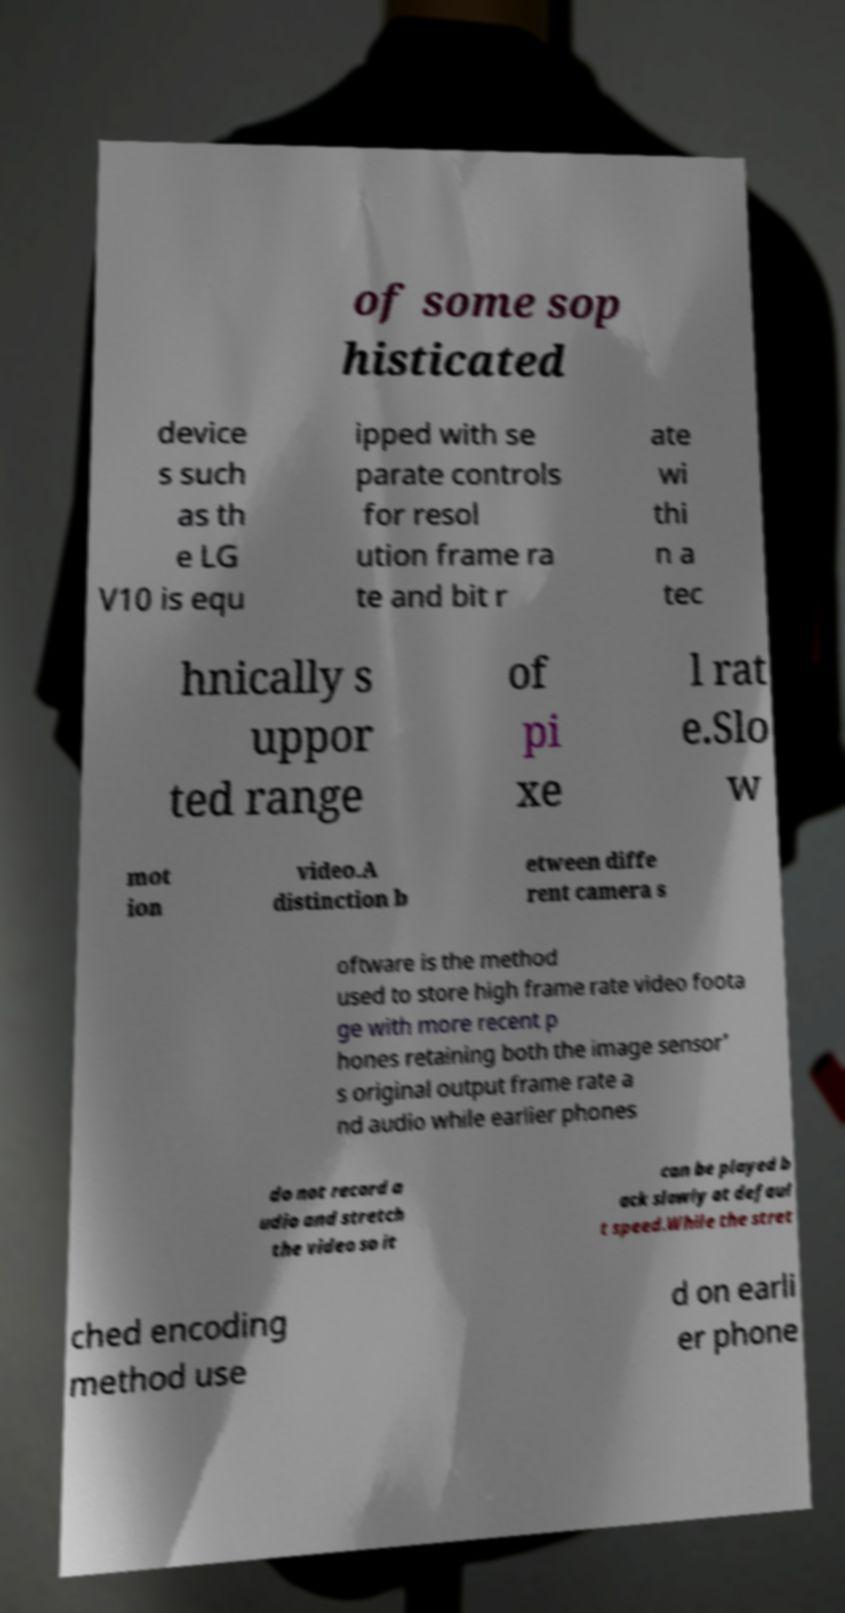I need the written content from this picture converted into text. Can you do that? of some sop histicated device s such as th e LG V10 is equ ipped with se parate controls for resol ution frame ra te and bit r ate wi thi n a tec hnically s uppor ted range of pi xe l rat e.Slo w mot ion video.A distinction b etween diffe rent camera s oftware is the method used to store high frame rate video foota ge with more recent p hones retaining both the image sensor' s original output frame rate a nd audio while earlier phones do not record a udio and stretch the video so it can be played b ack slowly at defaul t speed.While the stret ched encoding method use d on earli er phone 